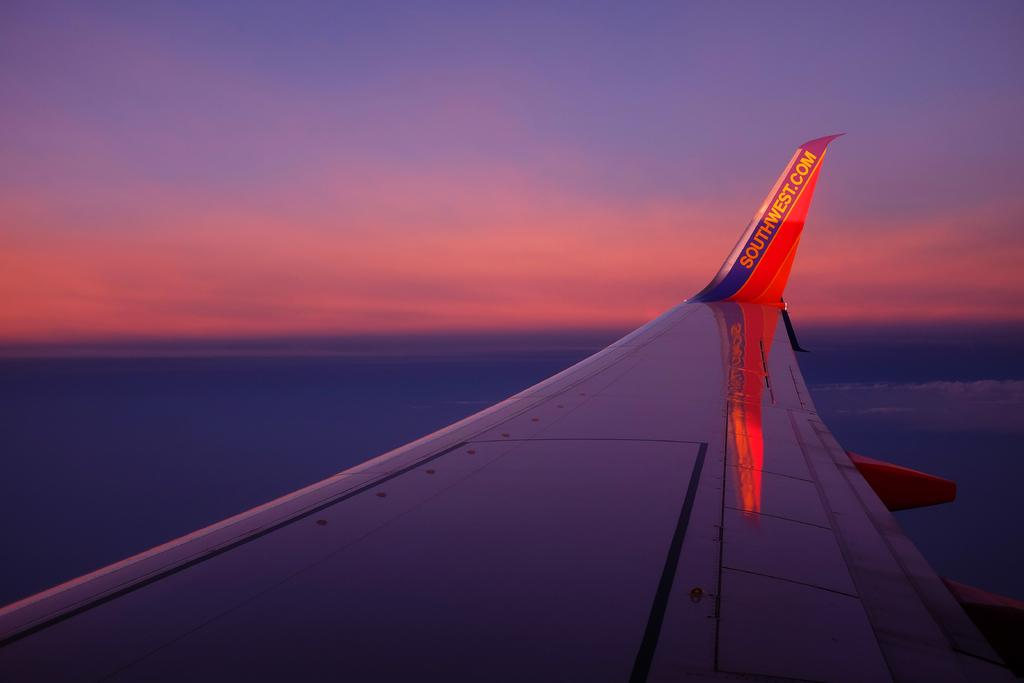Provide a one-sentence caption for the provided image. The wing of a southwest airliner is seen as it flies through the sky at sunset. 